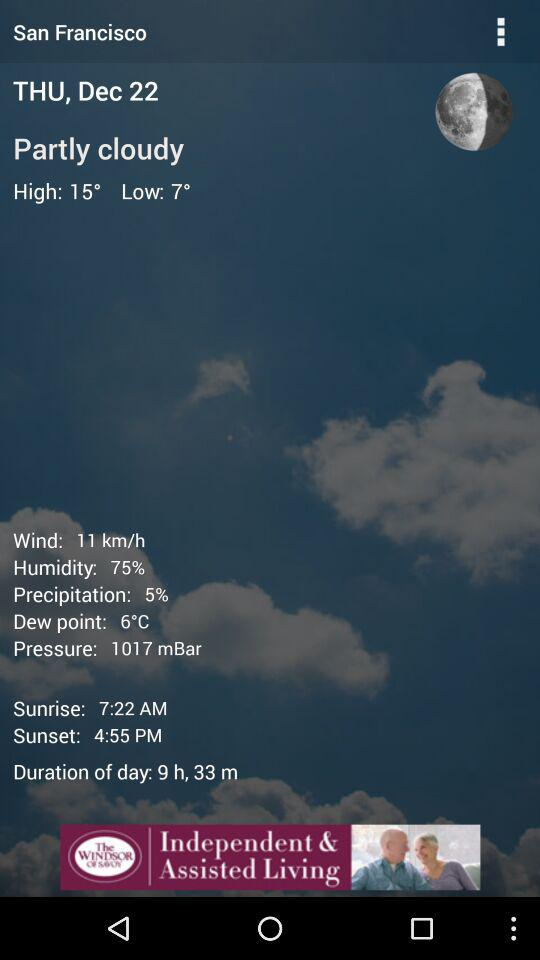Which option has a temperature of six degrees Celsius? The option that has a temperature of six degrees Celsius is "Dew point". 